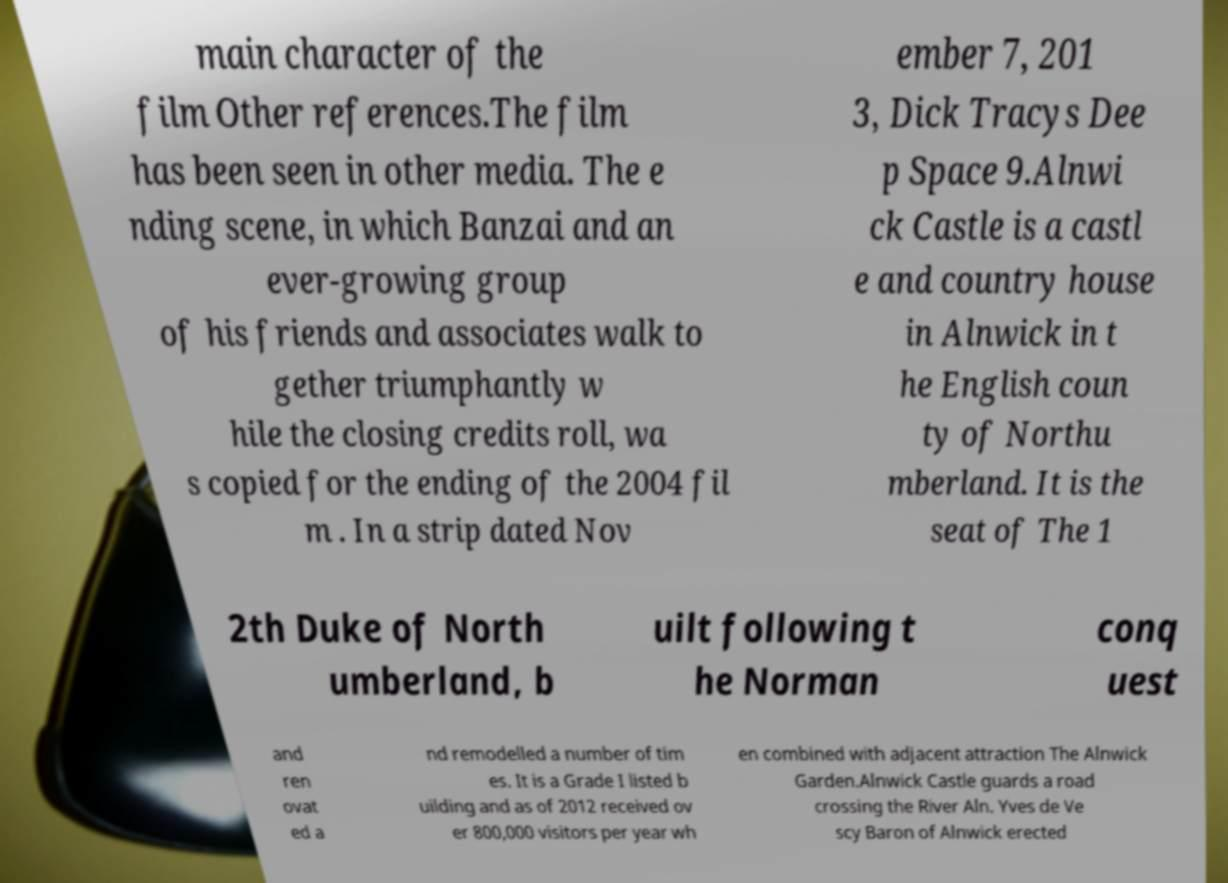Could you assist in decoding the text presented in this image and type it out clearly? main character of the film Other references.The film has been seen in other media. The e nding scene, in which Banzai and an ever-growing group of his friends and associates walk to gether triumphantly w hile the closing credits roll, wa s copied for the ending of the 2004 fil m . In a strip dated Nov ember 7, 201 3, Dick Tracys Dee p Space 9.Alnwi ck Castle is a castl e and country house in Alnwick in t he English coun ty of Northu mberland. It is the seat of The 1 2th Duke of North umberland, b uilt following t he Norman conq uest and ren ovat ed a nd remodelled a number of tim es. It is a Grade I listed b uilding and as of 2012 received ov er 800,000 visitors per year wh en combined with adjacent attraction The Alnwick Garden.Alnwick Castle guards a road crossing the River Aln. Yves de Ve scy Baron of Alnwick erected 